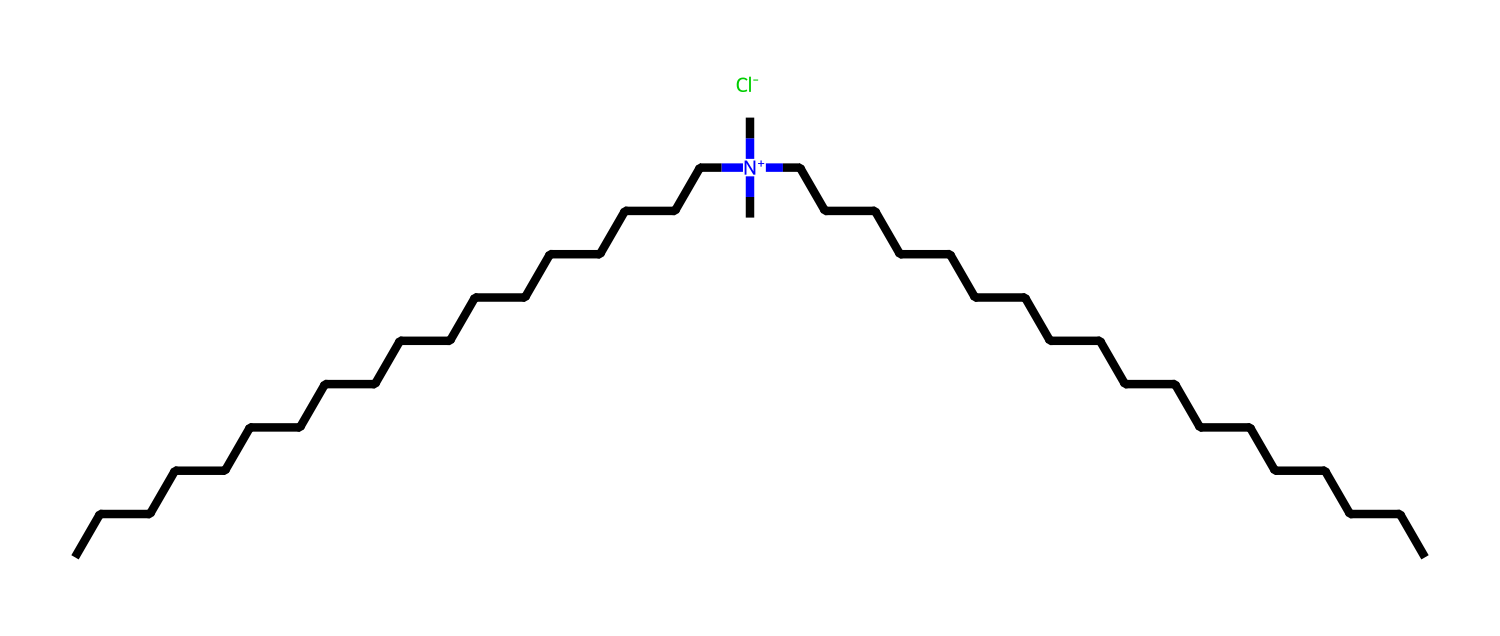What is the central atom in this quaternary ammonium compound? The structure indicates a nitrogen atom that carries a positive charge, which is typical for quaternary ammonium compounds. This nitrogen atom is central to its structure.
Answer: nitrogen How many carbon atoms are in this molecule? By counting the number of carbon atoms represented in the structure (analyzing the long alkyl chains and the substituents), there are a total of 36 carbon atoms in the entire molecule.
Answer: 36 What type of ions does this compound form when dissolved in water? Quaternary ammonium compounds dissociate into cationic (positively charged) ammonium ions and anions, in this case, the chloride ion is identified in the structure as Cl-.
Answer: chloride ion What properties of this compound could contribute to its antimicrobial effects? The positively charged ammonium ion allows for interaction with negatively charged surfaces of microbes, disrupting cell membranes, which is a key mechanism of antimicrobial action.
Answer: positively charged ammonium ion Does this compound have any hydrophilic or hydrophobic features? The long hydrocarbon chains contribute hydrophobic properties, while the positively charged ammonium group contributes some hydrophilic characteristics, making it amphiphilic.
Answer: amphiphilic How many nitrogen atoms are present in this chemical structure? The structure contains only one nitrogen atom, indicated by the single nitrogen symbol in the SMILES representation.
Answer: one 